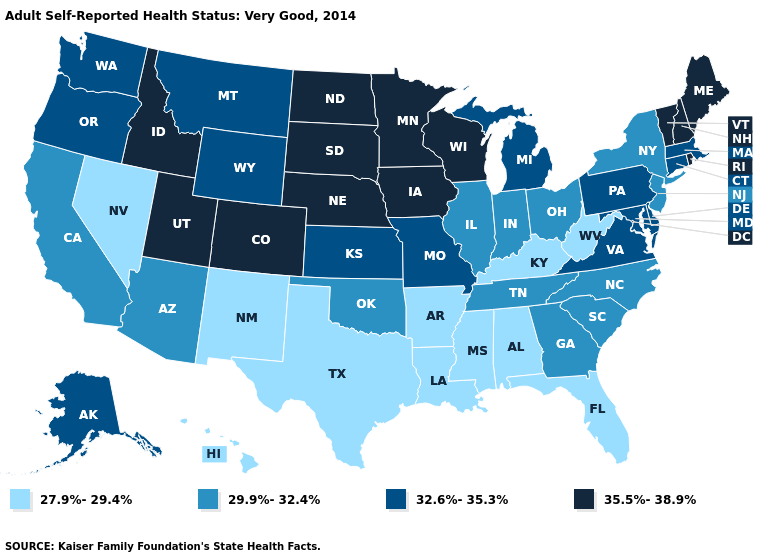Does Alaska have the lowest value in the USA?
Write a very short answer. No. What is the value of Connecticut?
Short answer required. 32.6%-35.3%. Name the states that have a value in the range 29.9%-32.4%?
Write a very short answer. Arizona, California, Georgia, Illinois, Indiana, New Jersey, New York, North Carolina, Ohio, Oklahoma, South Carolina, Tennessee. Does Oregon have the highest value in the USA?
Quick response, please. No. Which states have the lowest value in the USA?
Answer briefly. Alabama, Arkansas, Florida, Hawaii, Kentucky, Louisiana, Mississippi, Nevada, New Mexico, Texas, West Virginia. Does the first symbol in the legend represent the smallest category?
Write a very short answer. Yes. Among the states that border Illinois , does Kentucky have the lowest value?
Answer briefly. Yes. What is the lowest value in states that border Kansas?
Concise answer only. 29.9%-32.4%. Does the map have missing data?
Write a very short answer. No. Does Maryland have the highest value in the USA?
Short answer required. No. Does New Hampshire have the same value as Hawaii?
Answer briefly. No. What is the highest value in states that border Washington?
Quick response, please. 35.5%-38.9%. Does the first symbol in the legend represent the smallest category?
Quick response, please. Yes. Which states have the lowest value in the USA?
Quick response, please. Alabama, Arkansas, Florida, Hawaii, Kentucky, Louisiana, Mississippi, Nevada, New Mexico, Texas, West Virginia. What is the value of Minnesota?
Short answer required. 35.5%-38.9%. 